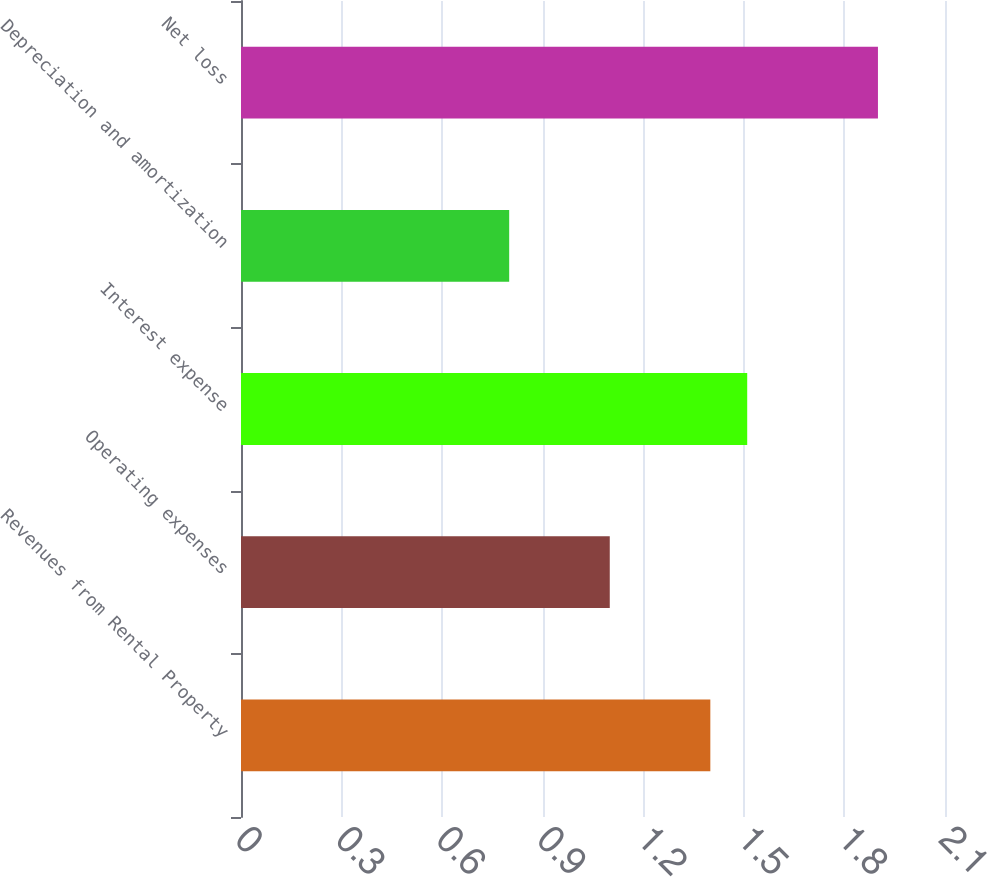<chart> <loc_0><loc_0><loc_500><loc_500><bar_chart><fcel>Revenues from Rental Property<fcel>Operating expenses<fcel>Interest expense<fcel>Depreciation and amortization<fcel>Net loss<nl><fcel>1.4<fcel>1.1<fcel>1.51<fcel>0.8<fcel>1.9<nl></chart> 